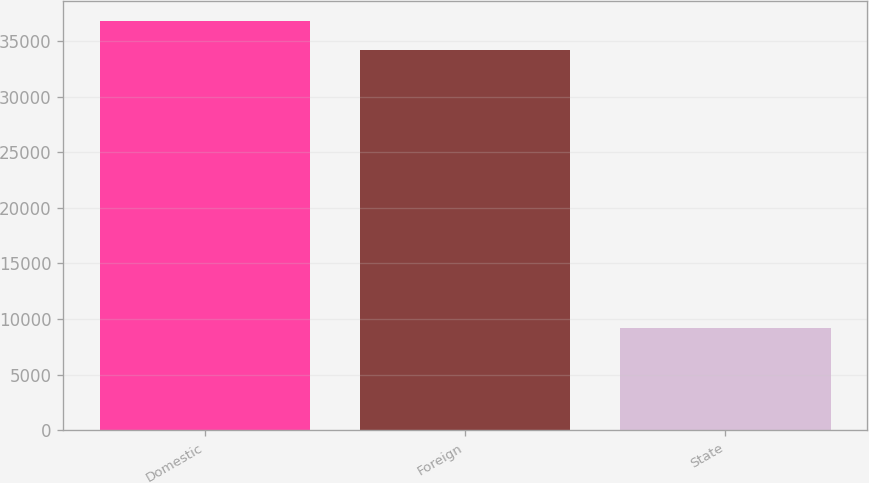Convert chart to OTSL. <chart><loc_0><loc_0><loc_500><loc_500><bar_chart><fcel>Domestic<fcel>Foreign<fcel>State<nl><fcel>36771.6<fcel>34232<fcel>9194<nl></chart> 